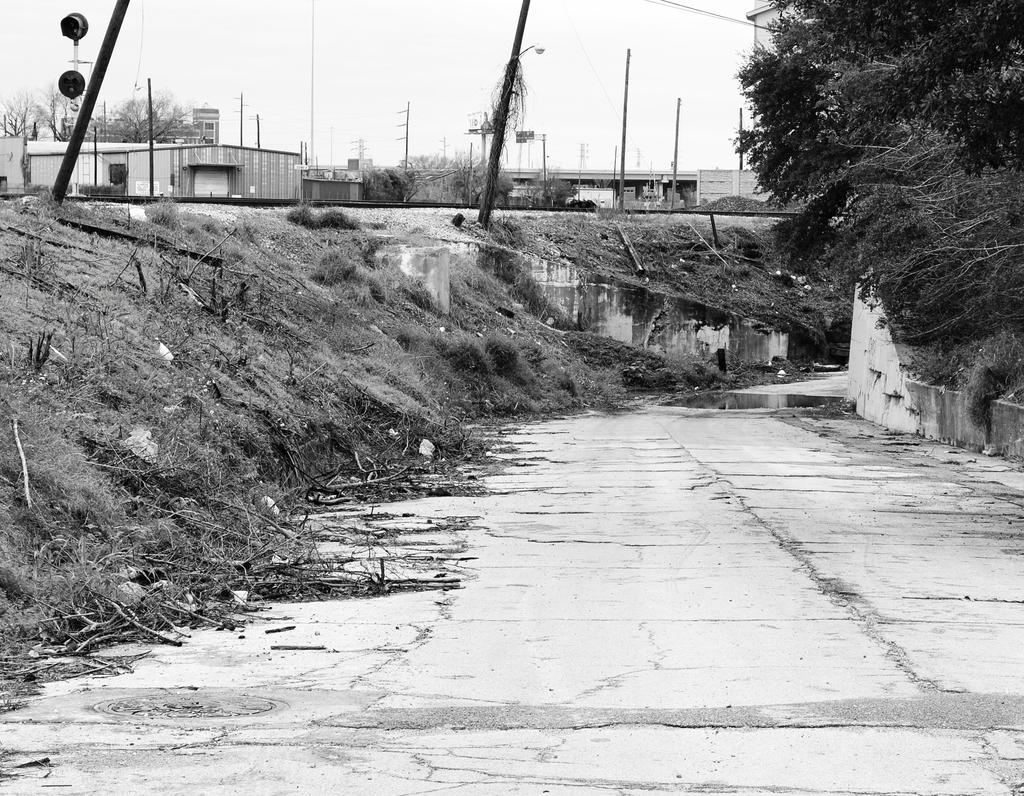What is the color scheme of the image? The image is black and white. What can be seen on the road in the image? There is water on the road in the image. What type of structures are present in the image? There are buildings in the image. What objects can be seen in the image that are used for supporting or guiding? There are poles in the image. What type of illumination is present in the image? There are lights in the image. What type of vegetation is present in the image? There are trees in the image. What part of the natural environment is visible in the background of the image? The sky is visible in the background of the image. What type of skin condition can be seen on the trees in the image? There is no mention of any skin condition on the trees in the image. The trees appear to be healthy and green. 